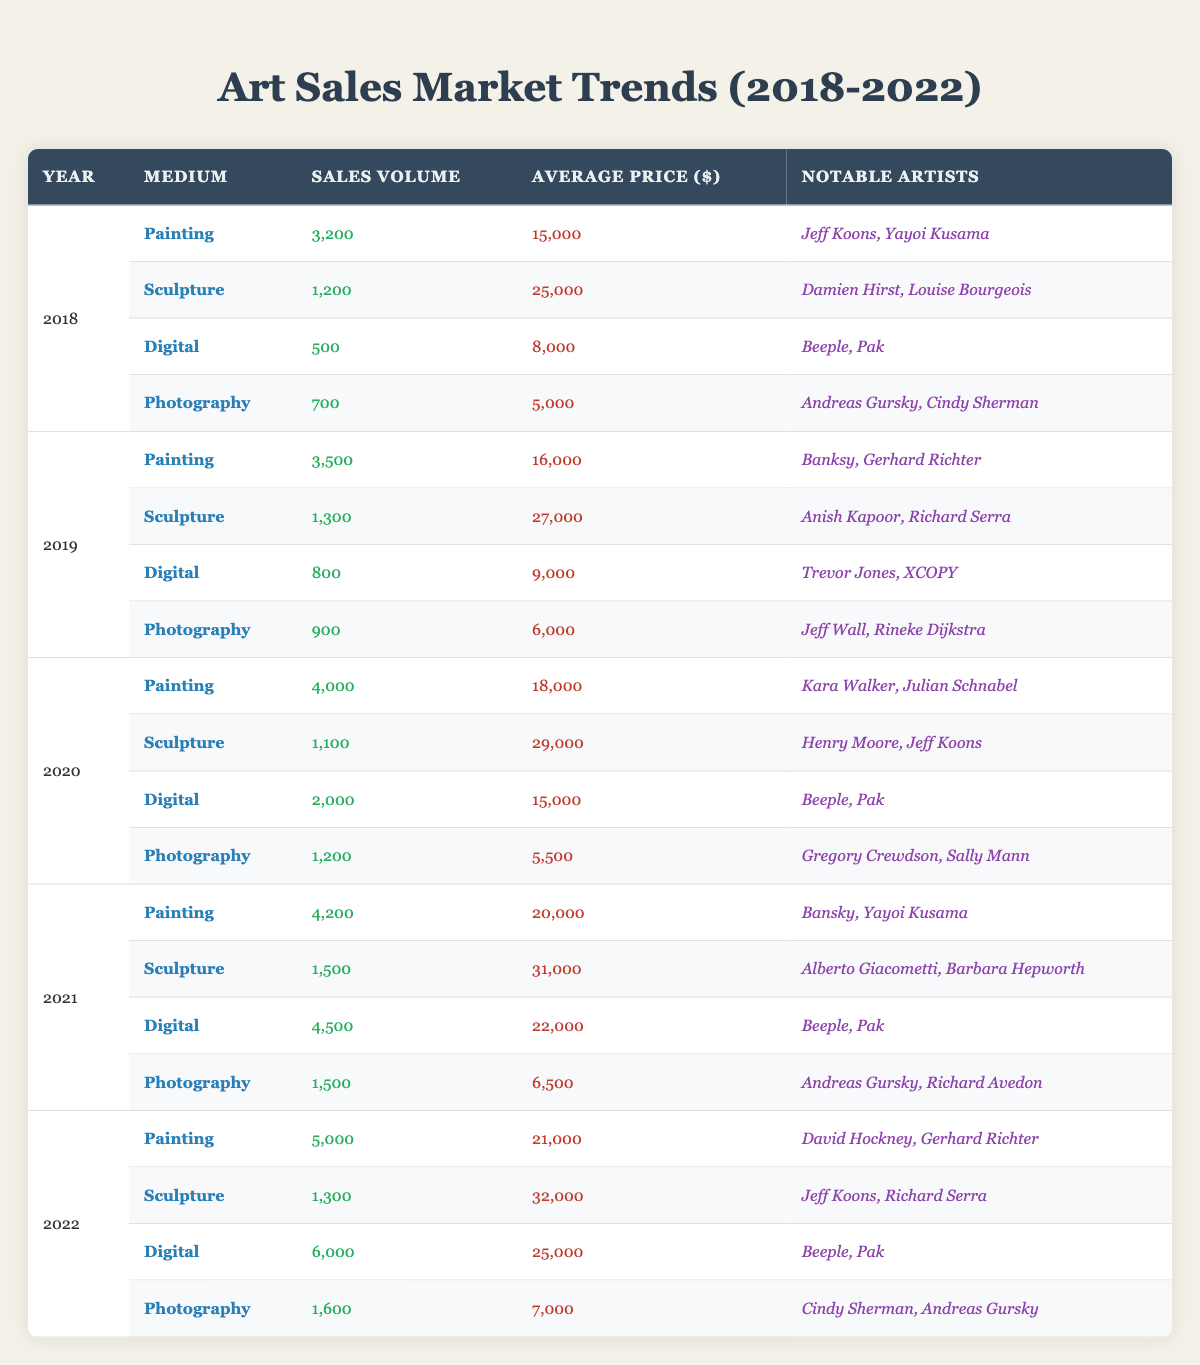What was the year with the highest sales volume for painting? In the data, the sales volumes for painting from 2018 to 2022 are 3200, 3500, 4000, 4200, and 5000, respectively. The highest value is 5000 in 2022.
Answer: 2022 What is the average price of sculptures sold in 2021? The average price of sculptures sold in 2021 is listed as 31,000.
Answer: 31,000 Which medium had the highest average price in 2020? The average prices for all mediums in 2020 are: Painting (18,000), Sculpture (29,000), Digital (15,000), and Photography (5,500). Sculpture has the highest average price at 29,000.
Answer: Sculpture Did digital art sales volume increase every year from 2018 to 2022? The sales volumes for digital art are 500, 800, 2000, 4500, and 6000 for the years 2018 to 2022. Since all values are increasing, it can be concluded that digital art sales volume did increase every year.
Answer: Yes What was the total sales volume for photography from 2018 to 2022? The sales volumes for photography are: 700 (2018), 900 (2019), 1200 (2020), 1500 (2021), and 1600 (2022). Summing these values gives: 700 + 900 + 1200 + 1500 + 1600 = 4900.
Answer: 4900 Which artist is noted for contributing to digital art sales in 2021? The notable artists for digital art sales in 2021 are Beeple and Pak as indicated in the table.
Answer: Beeple, Pak What is the difference in average price for painting between 2019 and 2022? The average prices for painting in 2019 and 2022 are 16,000 and 21,000, respectively. The difference is calculated as 21,000 - 16,000 = 5,000.
Answer: 5,000 What was the increase in sales volume for sculptures from 2018 to 2022? The sales volumes for sculptures from 2018 to 2022 are 1200, 1300, 1100, 1500, and 1300, respectively. The increase from 2018 to 2022 is 1300 - 1200 = 100.
Answer: 100 Which medium showed the most significant average price increase from 2018 to 2022? Comparing the average prices from 2018 to 2022: Painting (15,000 to 21,000, increase of 6,000), Sculpture (25,000 to 32,000, increase of 7,000), Digital (8,000 to 25,000, increase of 17,000), and Photography (5,000 to 7,000, increase of 2,000), the digital medium has the highest increase of 17,000.
Answer: Digital Was there a notable artist for painting sales in 2020? Yes, the table lists Kara Walker and Julian Schnabel as notable artists for painting sales in 2020.
Answer: Yes What is the total average price for all mediums in 2022? The average prices for 2022 are: Painting (21,000), Sculpture (32,000), Digital (25,000), and Photography (7,000). The total average price is calculated as 21,000 + 32,000 + 25,000 + 7,000 = 85,000.
Answer: 85,000 